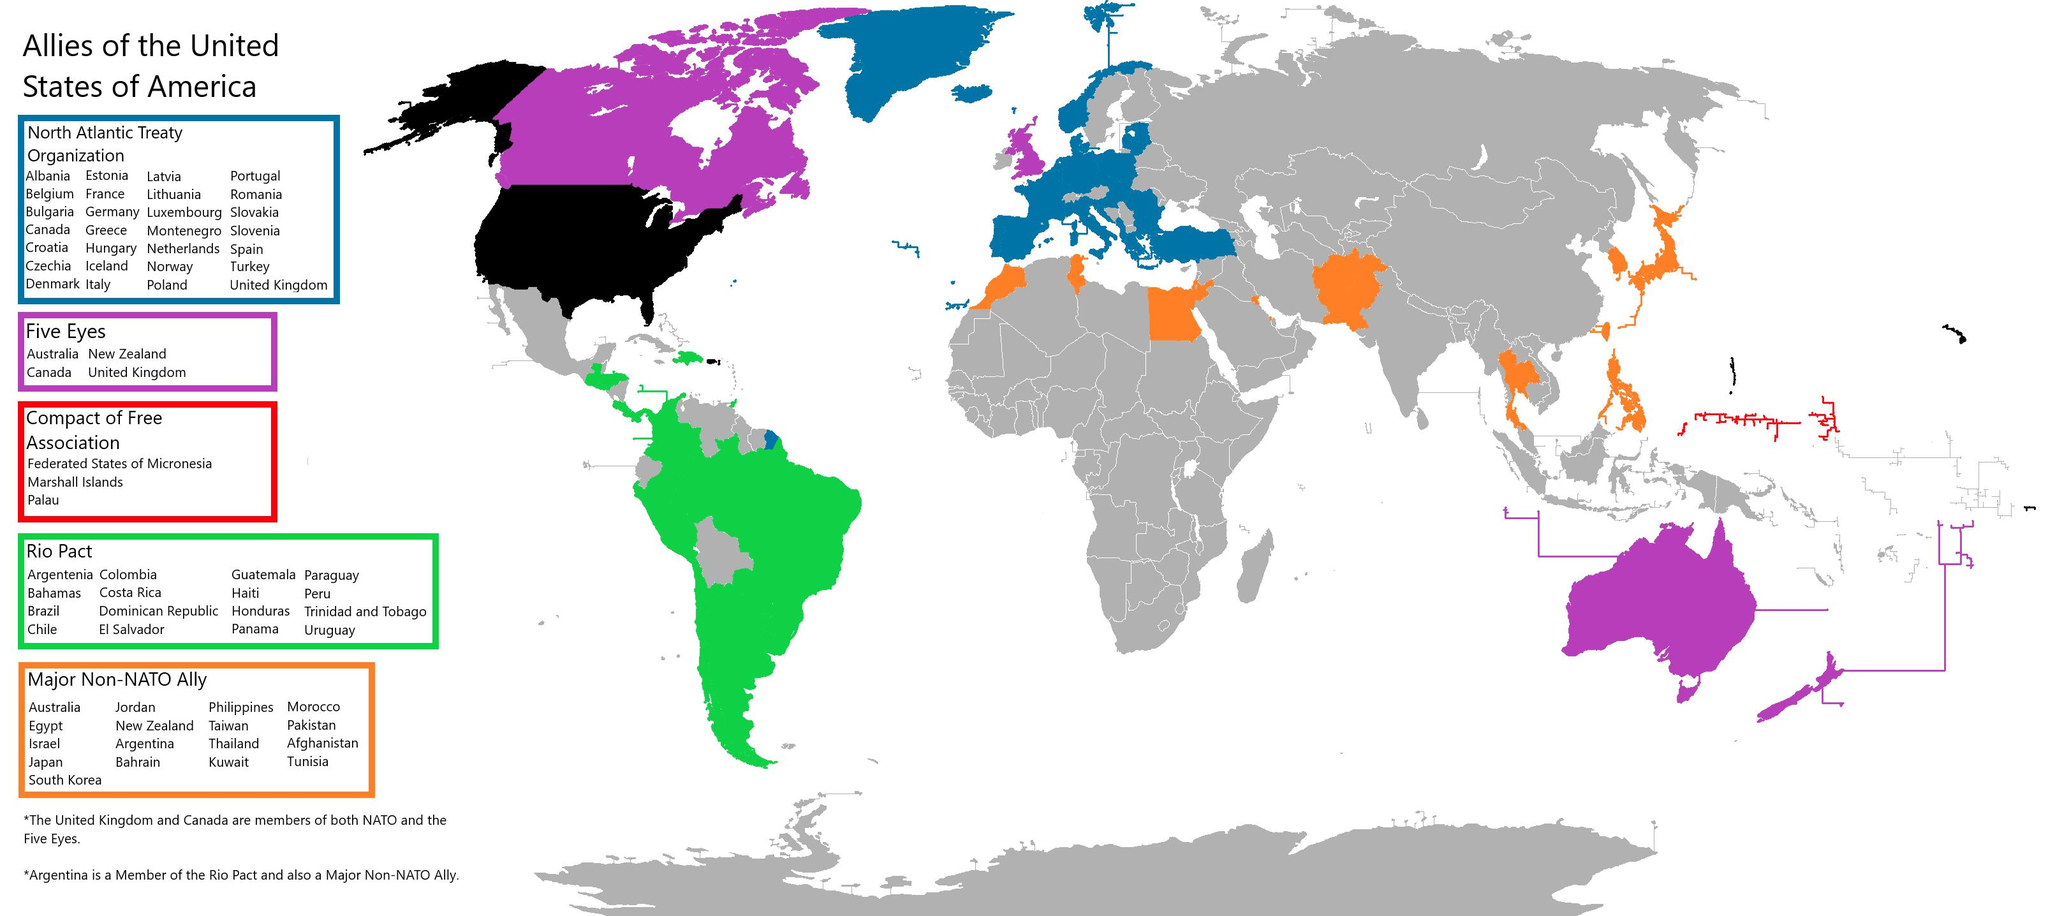Point out several critical features in this image. Thirty-three countries have signed the Compact of Free Association. The color used to represent the Rio Pact is green. The United States has 5 allies. The country of Romania is a member of the North Atlantic Treaty Organization, an alliance of countries committed to collective defense and peace. Uruguay is a member of the Rio Pact, which is an alliance of countries. 